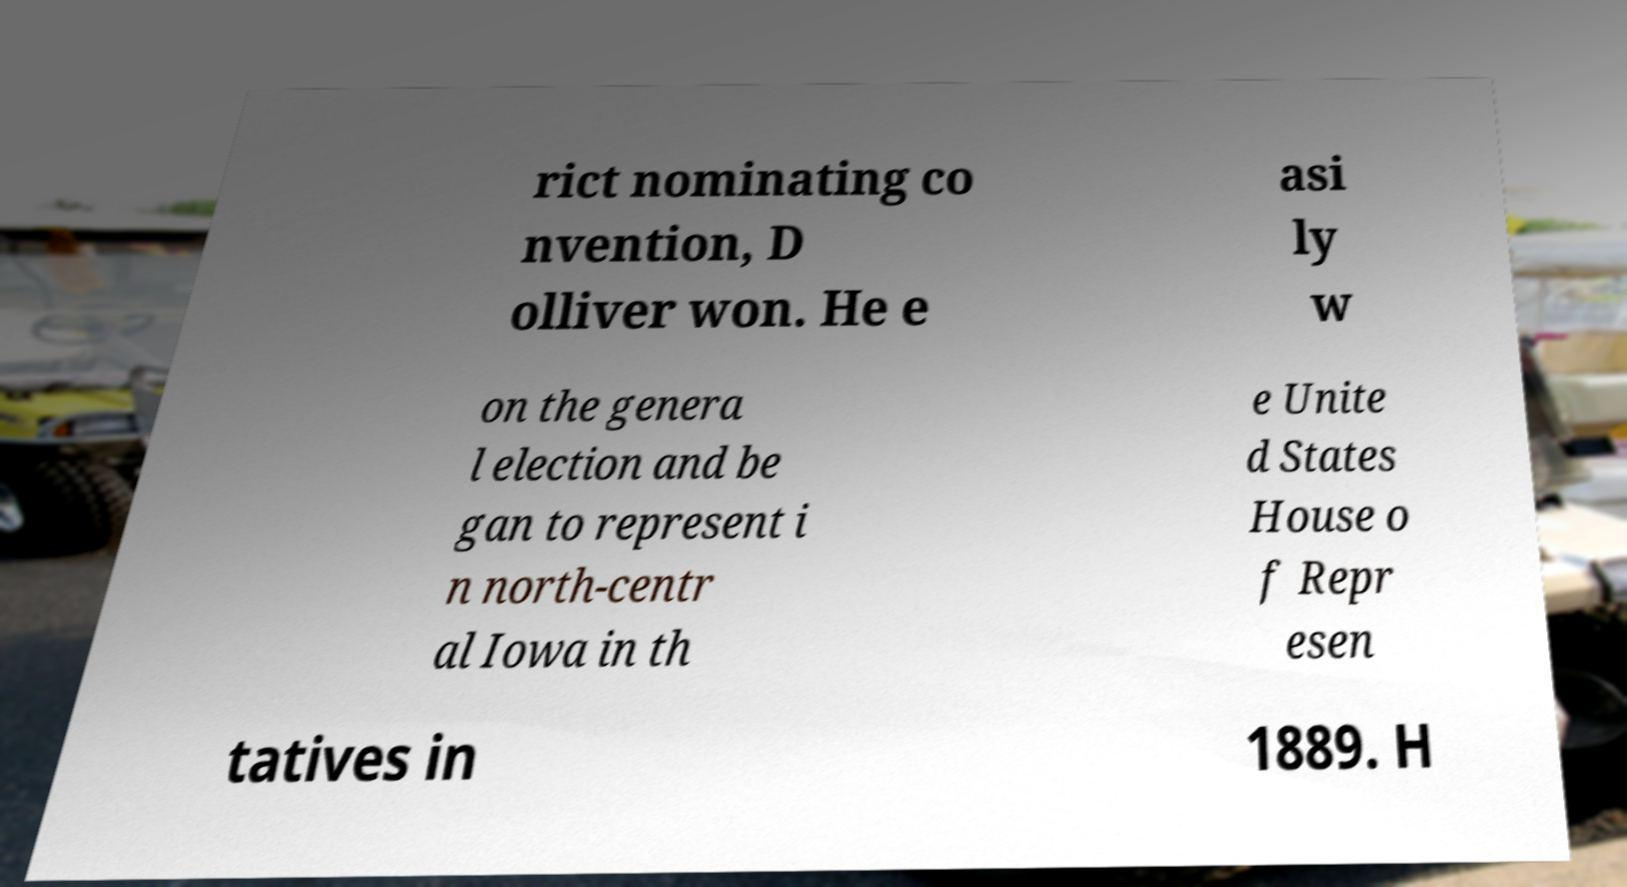Can you read and provide the text displayed in the image?This photo seems to have some interesting text. Can you extract and type it out for me? rict nominating co nvention, D olliver won. He e asi ly w on the genera l election and be gan to represent i n north-centr al Iowa in th e Unite d States House o f Repr esen tatives in 1889. H 